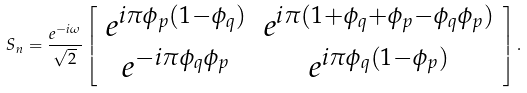<formula> <loc_0><loc_0><loc_500><loc_500>S _ { n } = \frac { e ^ { - i \omega } } { \sqrt { 2 } } \left [ \begin{array} [ c ] { c c } e ^ { i \pi \phi _ { p } ( 1 - \phi _ { q } ) } & e ^ { i \pi ( 1 + \phi _ { q } + \phi _ { p } - \phi _ { q } \phi _ { p } ) } \\ e ^ { - i \pi \phi _ { q } \phi _ { p } } & e ^ { i \pi \phi _ { q } ( 1 - \phi _ { p } ) } \end{array} \right ] .</formula> 